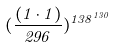<formula> <loc_0><loc_0><loc_500><loc_500>( \frac { ( 1 \cdot 1 ) } { 2 9 6 } ) ^ { 1 3 8 ^ { 1 3 0 } }</formula> 